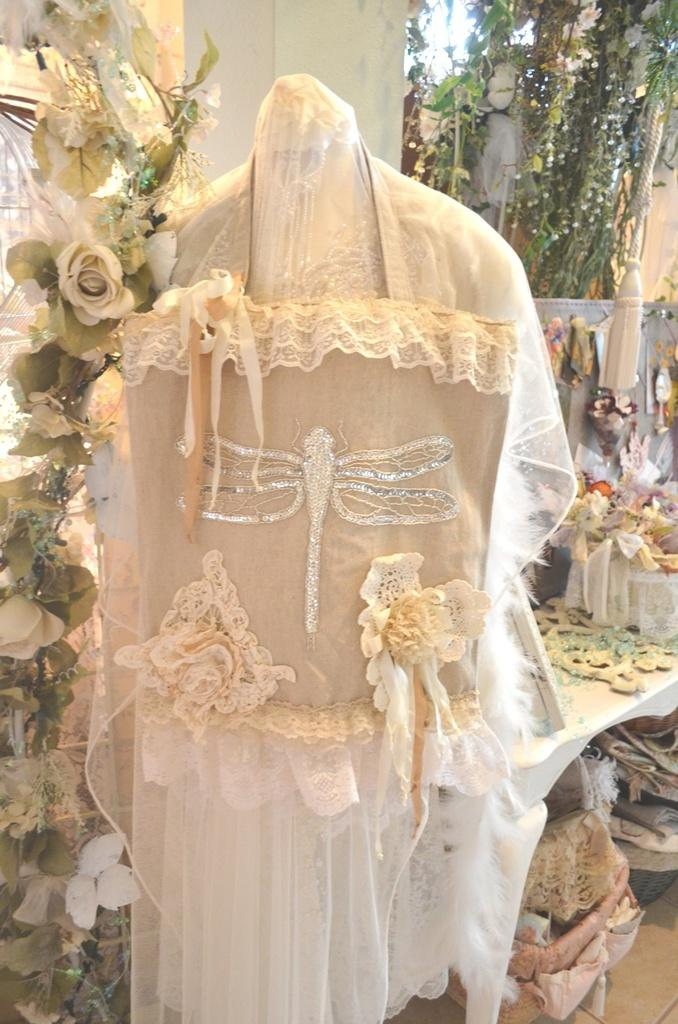What type of clothing is featured in the image? There is a dress in the image. What decorative elements can be seen on the left side of the image? There are decorative flowers on the left side of the image. What is located behind the dress in the image? There is a decorative plant and a wall behind the dress. What objects can be seen behind the dress? There are objects visible behind the dress. What type of popcorn is being served at the camp in the image? There is no popcorn or camp present in the image; it features a dress and decorative elements. How many birds are perched on the dress in the image? There are no birds present in the image; it features a dress and decorative elements. 